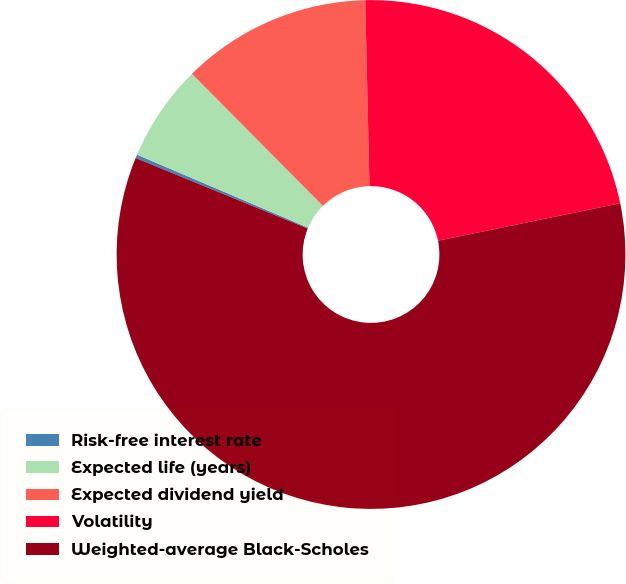Convert chart. <chart><loc_0><loc_0><loc_500><loc_500><pie_chart><fcel>Risk-free interest rate<fcel>Expected life (years)<fcel>Expected dividend yield<fcel>Volatility<fcel>Weighted-average Black-Scholes<nl><fcel>0.23%<fcel>6.15%<fcel>12.07%<fcel>22.13%<fcel>59.42%<nl></chart> 